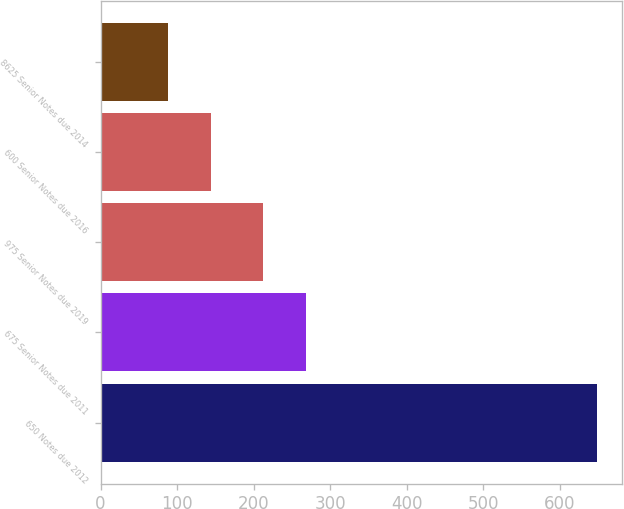<chart> <loc_0><loc_0><loc_500><loc_500><bar_chart><fcel>650 Notes due 2012<fcel>675 Senior Notes due 2011<fcel>975 Senior Notes due 2019<fcel>600 Senior Notes due 2016<fcel>8625 Senior Notes due 2014<nl><fcel>649<fcel>268.1<fcel>212<fcel>144.1<fcel>88<nl></chart> 